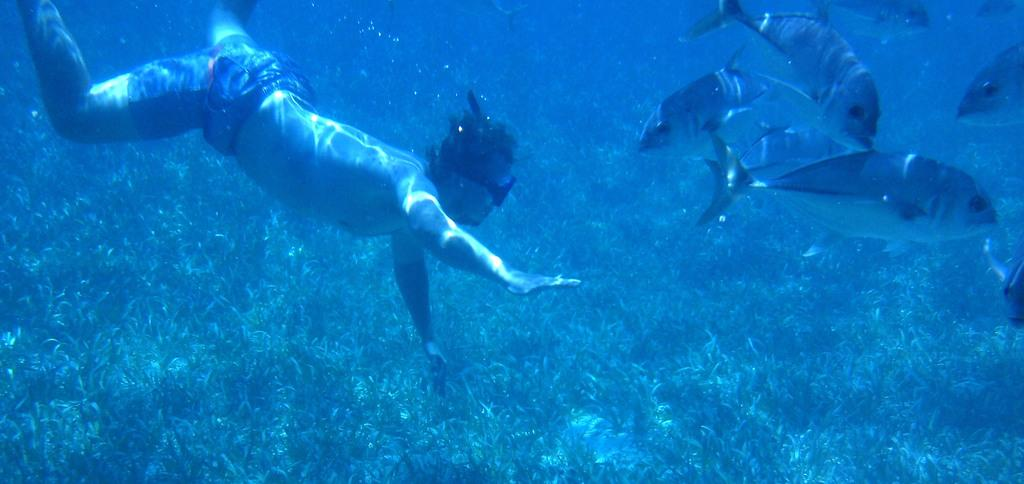What is the man doing in the water on the left side of the image? The man is in the water on the left side of the image. What else can be seen in the water besides the man? There are fishes in the water on the right side of the image. What type of vegetation is visible at the top of the image? There are plants visible at the top of the image. What type of potato is being used as a mouthpiece for the fishes in the image? There is no potato or mouthpiece present in the image; it features a man in the water and fishes in the water. What type of stem can be seen growing from the man's head in the image? There is no stem or growth on the man's head in the image. 